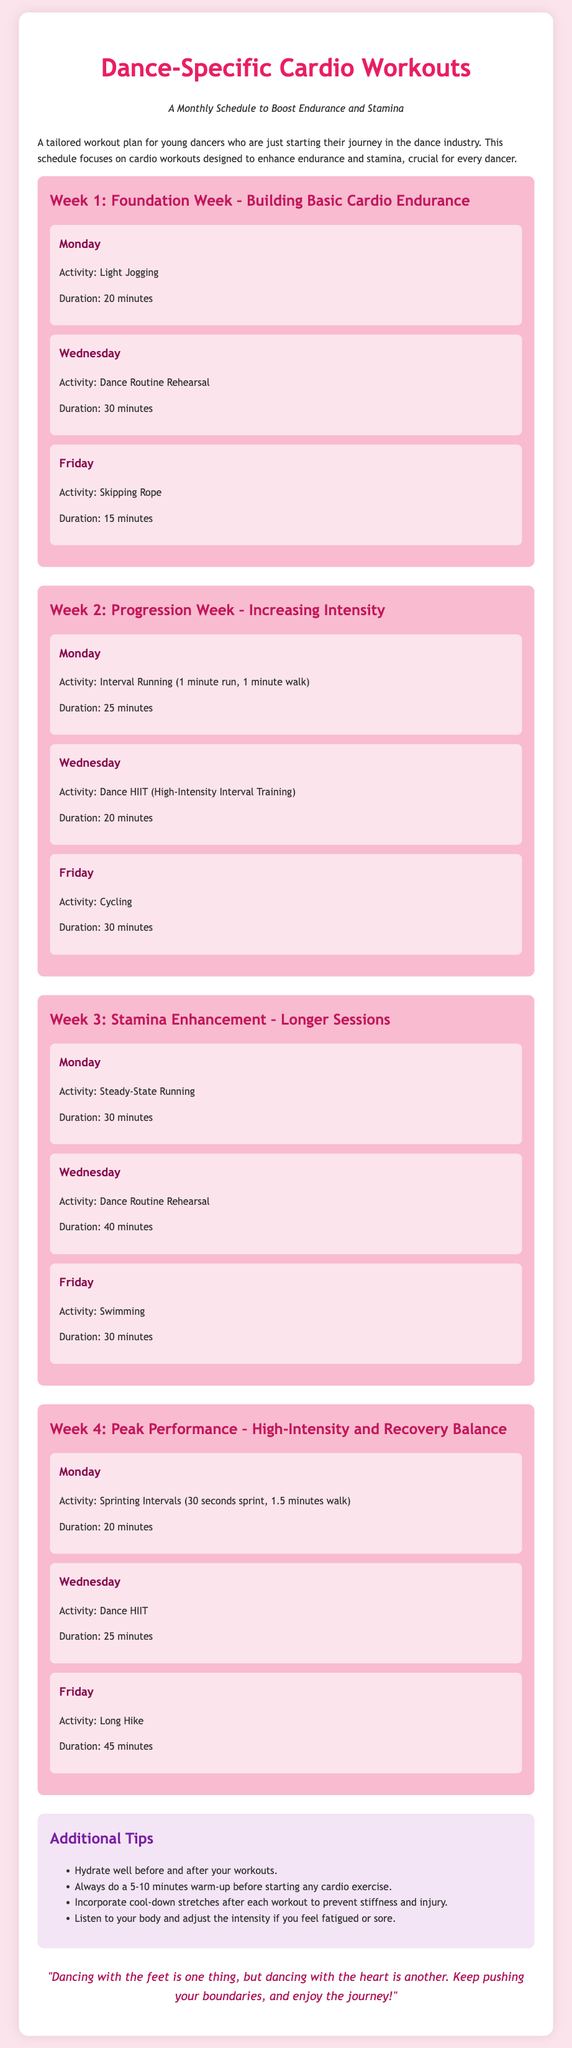What is the title of the document? The title is located in the header of the document, which states the main focus of the content.
Answer: Dance-Specific Cardio Workouts How many weeks are outlined in the workout plan? The document specifies a workout plan divided into four distinct weeks, each with its focus.
Answer: 4 What activity is scheduled for the first Wednesday? The activity listed for the first Wednesday in the schedule focuses on rehearsing specific dance routines.
Answer: Dance Routine Rehearsal What is the total duration of cardio workouts on Fridays in Week 2? The durations for the Friday workouts in Week 2 are given as 30 minutes for Cycling.
Answer: 30 minutes What is the focus of Week 3 in the workout plan? The description under Week 3 clearly indicates that the goal is to enhance stamina through longer workout sessions.
Answer: Stamina Enhancement How long should one warm up before starting a cardio exercise? The tips section provides recommended warm-up duration to prepare for workouts safely.
Answer: 5-10 minutes What type of workout is scheduled for the second Friday? This workout is categorized by a specific activity aimed at building endurance through low-impact exercise.
Answer: Swimming What should be done after each workout according to the tips? The tips section suggests incorporating specific post-workout stretches to aid recovery and prevent stiffness.
Answer: Cool-down stretches 